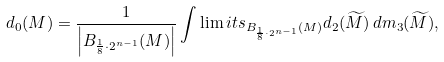<formula> <loc_0><loc_0><loc_500><loc_500>d _ { 0 } ( M ) = \frac { 1 } { \left | B _ { \frac { 1 } { 8 } \cdot 2 ^ { n - 1 } } ( M ) \right | } \int \lim i t s _ { B _ { \frac { 1 } { 8 } \cdot 2 ^ { n - 1 } } ( M ) } d _ { 2 } ( \widetilde { M } ) \, d m _ { 3 } ( \widetilde { M } ) ,</formula> 